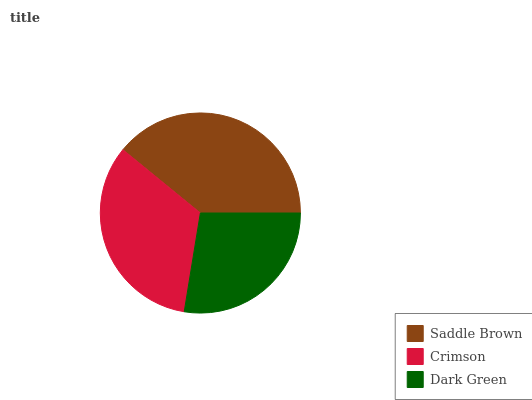Is Dark Green the minimum?
Answer yes or no. Yes. Is Saddle Brown the maximum?
Answer yes or no. Yes. Is Crimson the minimum?
Answer yes or no. No. Is Crimson the maximum?
Answer yes or no. No. Is Saddle Brown greater than Crimson?
Answer yes or no. Yes. Is Crimson less than Saddle Brown?
Answer yes or no. Yes. Is Crimson greater than Saddle Brown?
Answer yes or no. No. Is Saddle Brown less than Crimson?
Answer yes or no. No. Is Crimson the high median?
Answer yes or no. Yes. Is Crimson the low median?
Answer yes or no. Yes. Is Dark Green the high median?
Answer yes or no. No. Is Saddle Brown the low median?
Answer yes or no. No. 